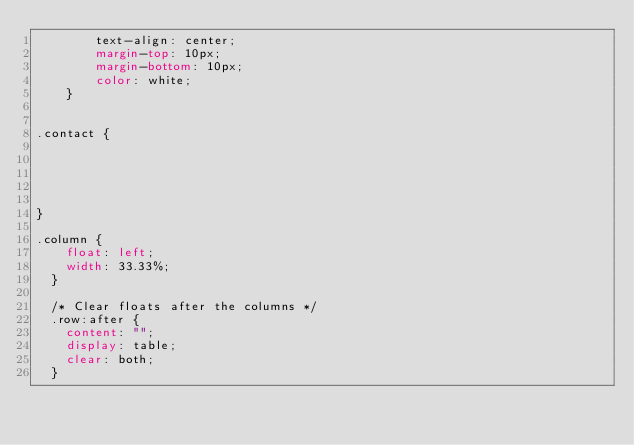Convert code to text. <code><loc_0><loc_0><loc_500><loc_500><_CSS_>        text-align: center;
        margin-top: 10px;
        margin-bottom: 10px;
        color: white;
    }

   
.contact {
   
   
   
   
  
}

.column {
    float: left;
    width: 33.33%;
  }
  
  /* Clear floats after the columns */
  .row:after {
    content: "";
    display: table;
    clear: both;
  }
    












</code> 